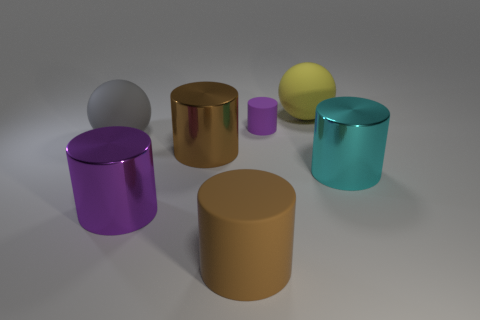Subtract all cyan shiny cylinders. How many cylinders are left? 4 Subtract 2 cylinders. How many cylinders are left? 3 Add 2 big green matte cylinders. How many objects exist? 9 Subtract all brown cylinders. How many cylinders are left? 3 Subtract all brown cubes. How many brown cylinders are left? 2 Subtract all cylinders. How many objects are left? 2 Add 6 tiny gray matte blocks. How many tiny gray matte blocks exist? 6 Subtract 0 green blocks. How many objects are left? 7 Subtract all green cylinders. Subtract all yellow balls. How many cylinders are left? 5 Subtract all large yellow things. Subtract all big brown matte cylinders. How many objects are left? 5 